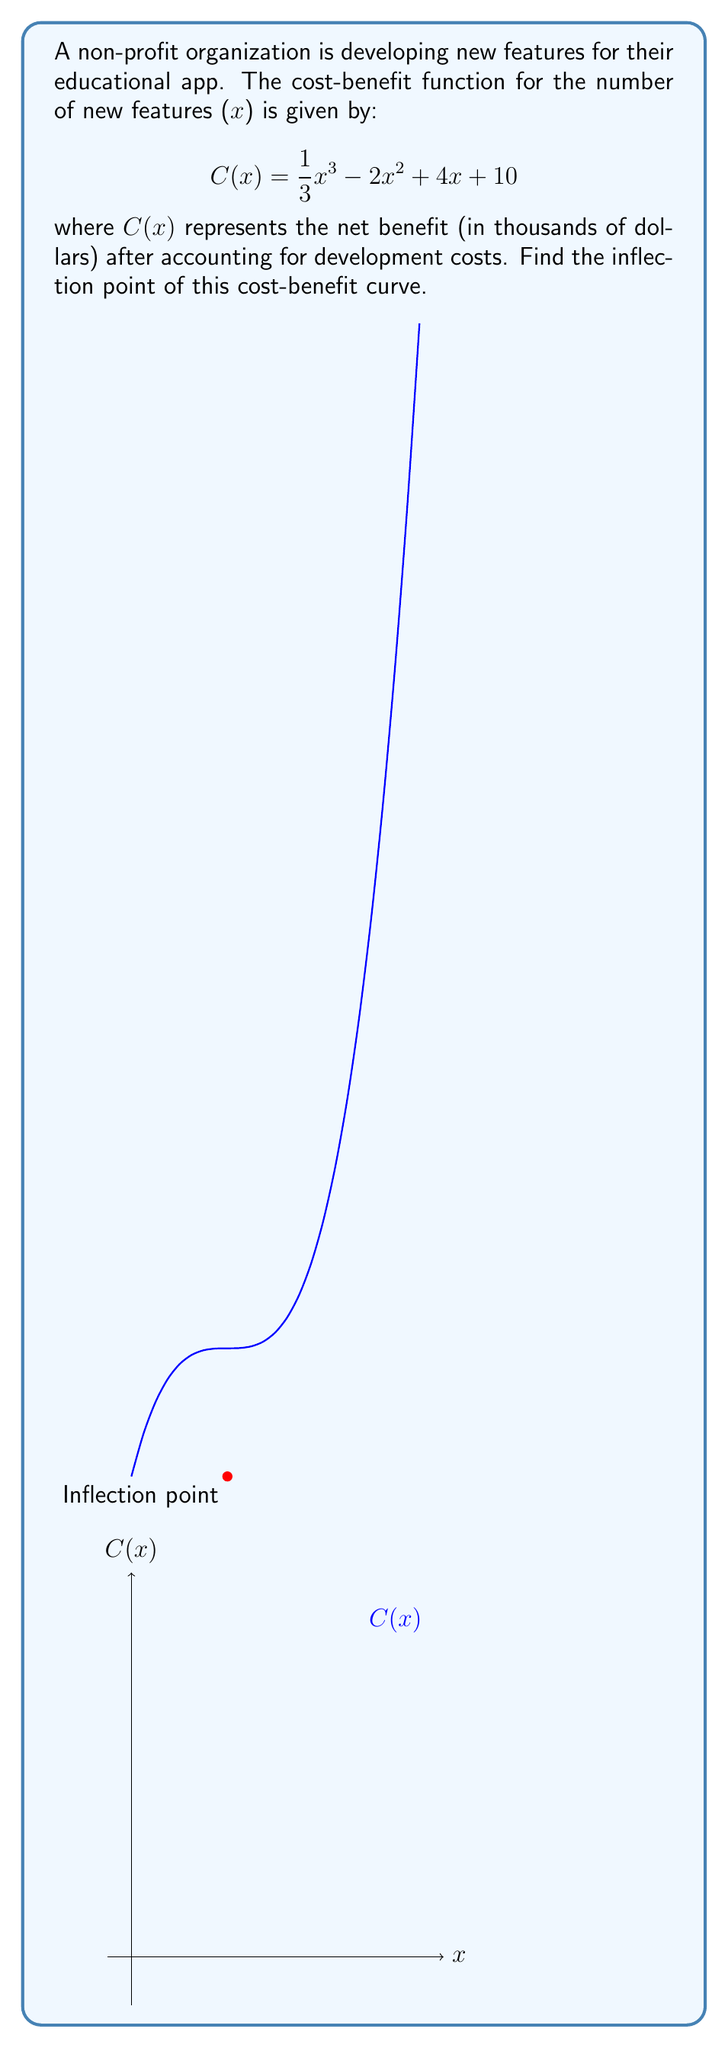Can you solve this math problem? To find the inflection point, we need to follow these steps:

1) The inflection point occurs where the second derivative of C(x) equals zero.

2) First, let's find the first derivative:
   $$C'(x) = x^2 - 4x + 4$$

3) Now, let's find the second derivative:
   $$C''(x) = 2x - 4$$

4) Set the second derivative equal to zero and solve for x:
   $$2x - 4 = 0$$
   $$2x = 4$$
   $$x = 2$$

5) This x-value is the x-coordinate of the inflection point.

6) To find the y-coordinate, we plug x = 2 into the original function:
   $$C(2) = \frac{1}{3}(2)^3 - 2(2)^2 + 4(2) + 10$$
   $$= \frac{8}{3} - 8 + 8 + 10$$
   $$= \frac{8}{3} + 10$$
   $$= \frac{38}{3}$$

Therefore, the inflection point is (2, 38/3) or approximately (2, 12.67).
Answer: (2, $\frac{38}{3}$) 